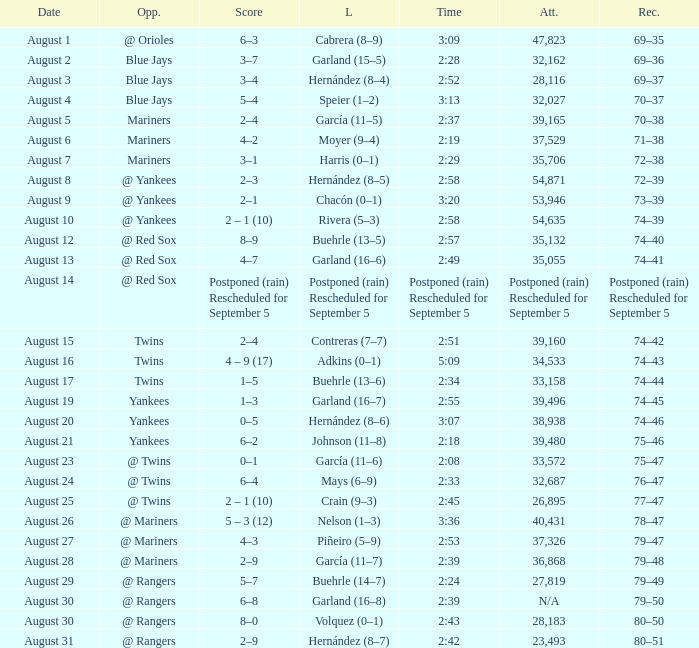Who lost on August 27? Piñeiro (5–9). 